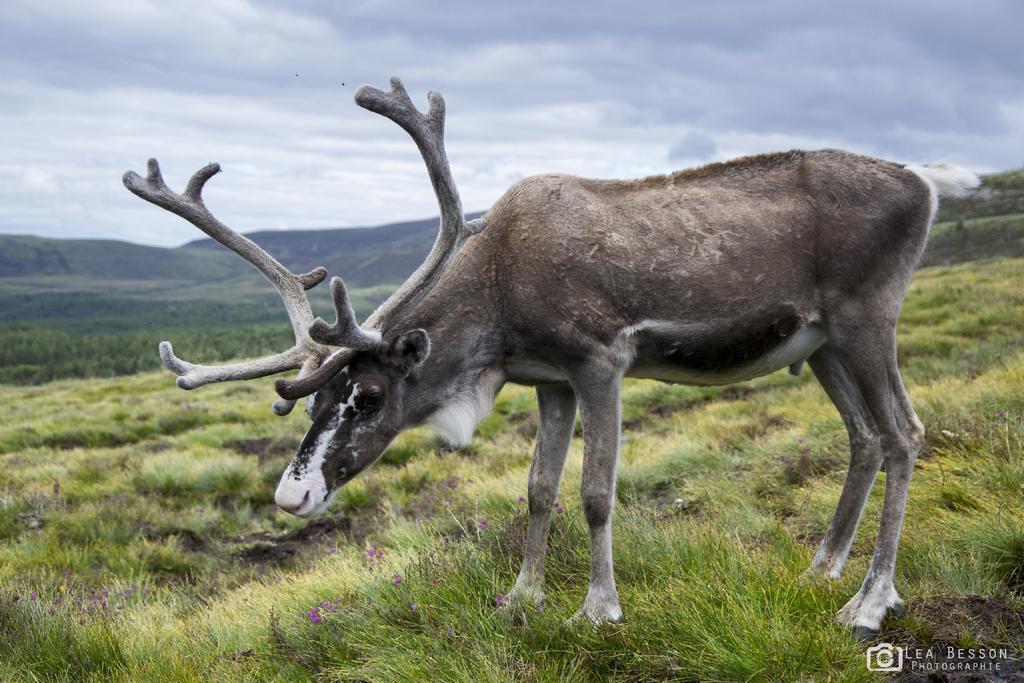How would you summarize this image in a sentence or two? In this image in the front there is an animal. In the background there is grass on the ground, there are trees and there are mountains and the sky is cloudy. 